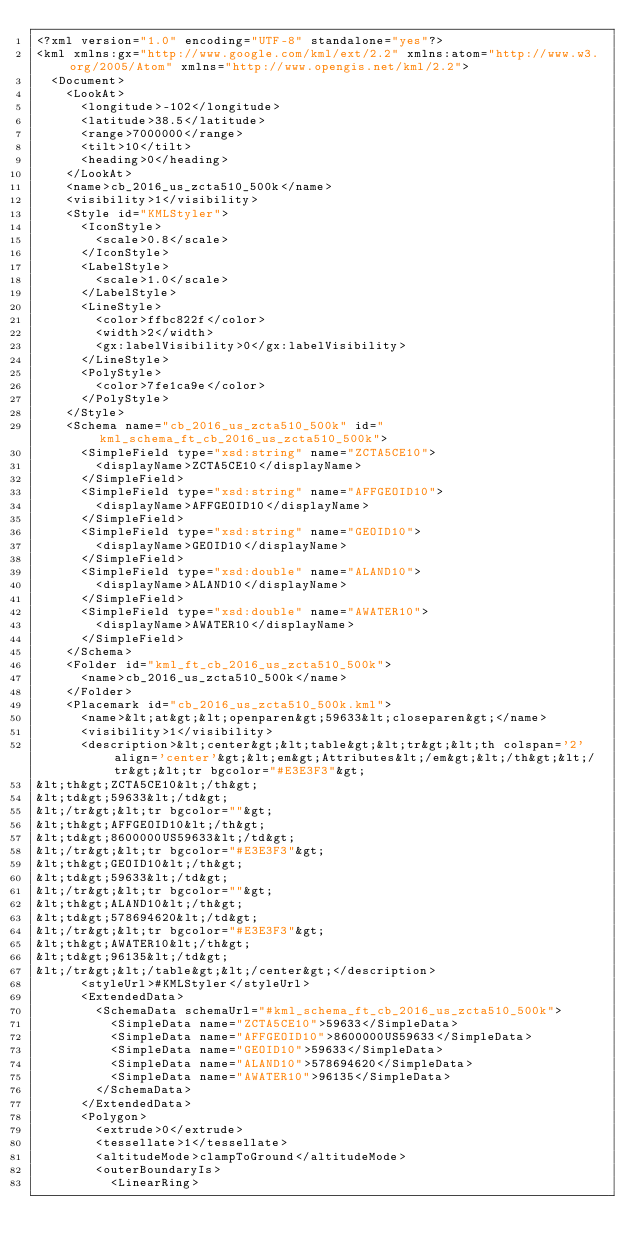<code> <loc_0><loc_0><loc_500><loc_500><_XML_><?xml version="1.0" encoding="UTF-8" standalone="yes"?>
<kml xmlns:gx="http://www.google.com/kml/ext/2.2" xmlns:atom="http://www.w3.org/2005/Atom" xmlns="http://www.opengis.net/kml/2.2">
  <Document>
    <LookAt>
      <longitude>-102</longitude>
      <latitude>38.5</latitude>
      <range>7000000</range>
      <tilt>10</tilt>
      <heading>0</heading>
    </LookAt>
    <name>cb_2016_us_zcta510_500k</name>
    <visibility>1</visibility>
    <Style id="KMLStyler">
      <IconStyle>
        <scale>0.8</scale>
      </IconStyle>
      <LabelStyle>
        <scale>1.0</scale>
      </LabelStyle>
      <LineStyle>
        <color>ffbc822f</color>
        <width>2</width>
        <gx:labelVisibility>0</gx:labelVisibility>
      </LineStyle>
      <PolyStyle>
        <color>7fe1ca9e</color>
      </PolyStyle>
    </Style>
    <Schema name="cb_2016_us_zcta510_500k" id="kml_schema_ft_cb_2016_us_zcta510_500k">
      <SimpleField type="xsd:string" name="ZCTA5CE10">
        <displayName>ZCTA5CE10</displayName>
      </SimpleField>
      <SimpleField type="xsd:string" name="AFFGEOID10">
        <displayName>AFFGEOID10</displayName>
      </SimpleField>
      <SimpleField type="xsd:string" name="GEOID10">
        <displayName>GEOID10</displayName>
      </SimpleField>
      <SimpleField type="xsd:double" name="ALAND10">
        <displayName>ALAND10</displayName>
      </SimpleField>
      <SimpleField type="xsd:double" name="AWATER10">
        <displayName>AWATER10</displayName>
      </SimpleField>
    </Schema>
    <Folder id="kml_ft_cb_2016_us_zcta510_500k">
      <name>cb_2016_us_zcta510_500k</name>
    </Folder>
    <Placemark id="cb_2016_us_zcta510_500k.kml">
      <name>&lt;at&gt;&lt;openparen&gt;59633&lt;closeparen&gt;</name>
      <visibility>1</visibility>
      <description>&lt;center&gt;&lt;table&gt;&lt;tr&gt;&lt;th colspan='2' align='center'&gt;&lt;em&gt;Attributes&lt;/em&gt;&lt;/th&gt;&lt;/tr&gt;&lt;tr bgcolor="#E3E3F3"&gt;
&lt;th&gt;ZCTA5CE10&lt;/th&gt;
&lt;td&gt;59633&lt;/td&gt;
&lt;/tr&gt;&lt;tr bgcolor=""&gt;
&lt;th&gt;AFFGEOID10&lt;/th&gt;
&lt;td&gt;8600000US59633&lt;/td&gt;
&lt;/tr&gt;&lt;tr bgcolor="#E3E3F3"&gt;
&lt;th&gt;GEOID10&lt;/th&gt;
&lt;td&gt;59633&lt;/td&gt;
&lt;/tr&gt;&lt;tr bgcolor=""&gt;
&lt;th&gt;ALAND10&lt;/th&gt;
&lt;td&gt;578694620&lt;/td&gt;
&lt;/tr&gt;&lt;tr bgcolor="#E3E3F3"&gt;
&lt;th&gt;AWATER10&lt;/th&gt;
&lt;td&gt;96135&lt;/td&gt;
&lt;/tr&gt;&lt;/table&gt;&lt;/center&gt;</description>
      <styleUrl>#KMLStyler</styleUrl>
      <ExtendedData>
        <SchemaData schemaUrl="#kml_schema_ft_cb_2016_us_zcta510_500k">
          <SimpleData name="ZCTA5CE10">59633</SimpleData>
          <SimpleData name="AFFGEOID10">8600000US59633</SimpleData>
          <SimpleData name="GEOID10">59633</SimpleData>
          <SimpleData name="ALAND10">578694620</SimpleData>
          <SimpleData name="AWATER10">96135</SimpleData>
        </SchemaData>
      </ExtendedData>
      <Polygon>
        <extrude>0</extrude>
        <tessellate>1</tessellate>
        <altitudeMode>clampToGround</altitudeMode>
        <outerBoundaryIs>
          <LinearRing></code> 